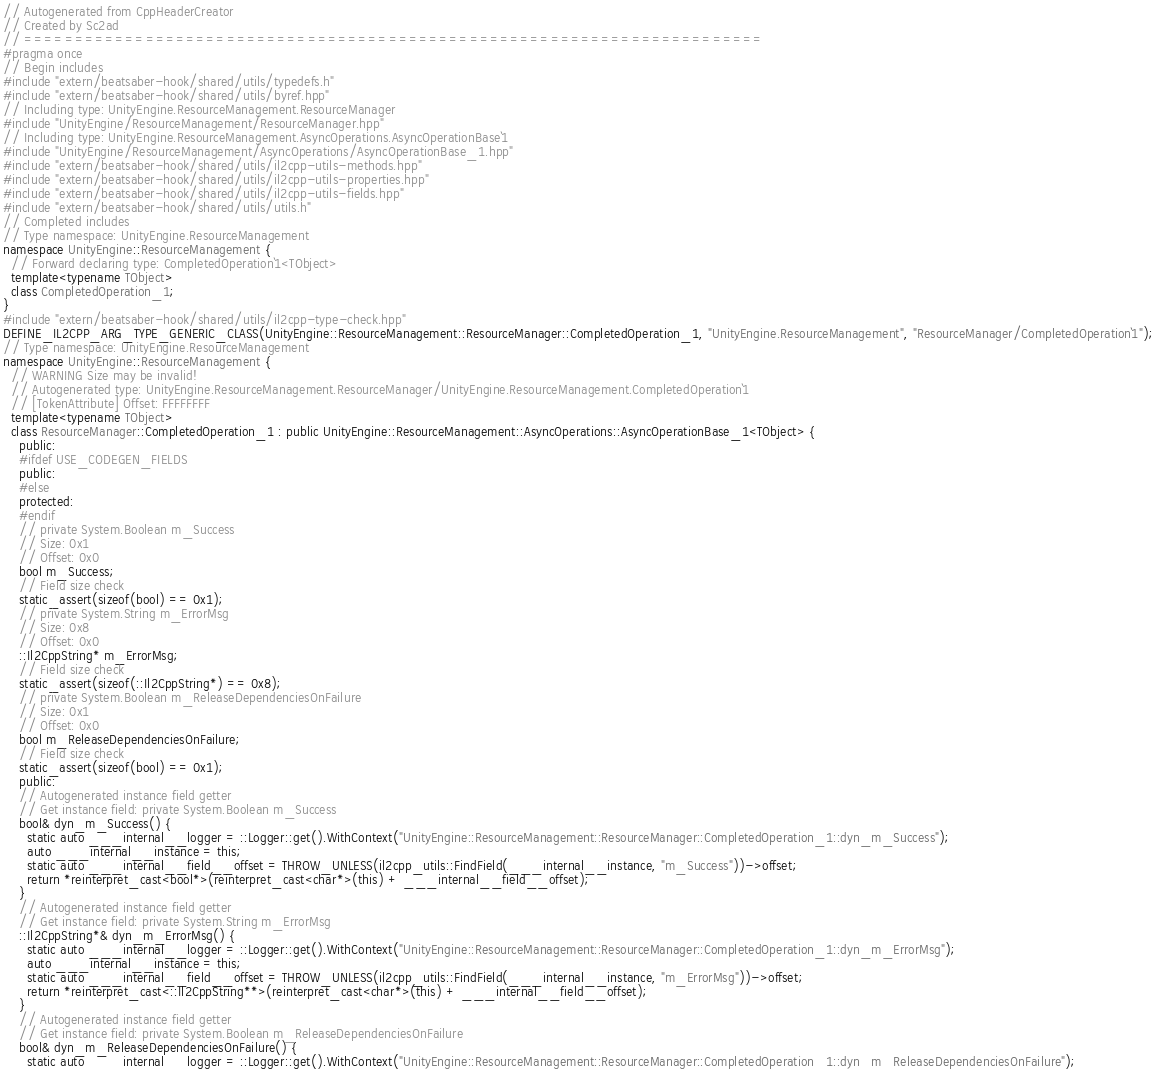<code> <loc_0><loc_0><loc_500><loc_500><_C++_>// Autogenerated from CppHeaderCreator
// Created by Sc2ad
// =========================================================================
#pragma once
// Begin includes
#include "extern/beatsaber-hook/shared/utils/typedefs.h"
#include "extern/beatsaber-hook/shared/utils/byref.hpp"
// Including type: UnityEngine.ResourceManagement.ResourceManager
#include "UnityEngine/ResourceManagement/ResourceManager.hpp"
// Including type: UnityEngine.ResourceManagement.AsyncOperations.AsyncOperationBase`1
#include "UnityEngine/ResourceManagement/AsyncOperations/AsyncOperationBase_1.hpp"
#include "extern/beatsaber-hook/shared/utils/il2cpp-utils-methods.hpp"
#include "extern/beatsaber-hook/shared/utils/il2cpp-utils-properties.hpp"
#include "extern/beatsaber-hook/shared/utils/il2cpp-utils-fields.hpp"
#include "extern/beatsaber-hook/shared/utils/utils.h"
// Completed includes
// Type namespace: UnityEngine.ResourceManagement
namespace UnityEngine::ResourceManagement {
  // Forward declaring type: CompletedOperation`1<TObject>
  template<typename TObject>
  class CompletedOperation_1;
}
#include "extern/beatsaber-hook/shared/utils/il2cpp-type-check.hpp"
DEFINE_IL2CPP_ARG_TYPE_GENERIC_CLASS(UnityEngine::ResourceManagement::ResourceManager::CompletedOperation_1, "UnityEngine.ResourceManagement", "ResourceManager/CompletedOperation`1");
// Type namespace: UnityEngine.ResourceManagement
namespace UnityEngine::ResourceManagement {
  // WARNING Size may be invalid!
  // Autogenerated type: UnityEngine.ResourceManagement.ResourceManager/UnityEngine.ResourceManagement.CompletedOperation`1
  // [TokenAttribute] Offset: FFFFFFFF
  template<typename TObject>
  class ResourceManager::CompletedOperation_1 : public UnityEngine::ResourceManagement::AsyncOperations::AsyncOperationBase_1<TObject> {
    public:
    #ifdef USE_CODEGEN_FIELDS
    public:
    #else
    protected:
    #endif
    // private System.Boolean m_Success
    // Size: 0x1
    // Offset: 0x0
    bool m_Success;
    // Field size check
    static_assert(sizeof(bool) == 0x1);
    // private System.String m_ErrorMsg
    // Size: 0x8
    // Offset: 0x0
    ::Il2CppString* m_ErrorMsg;
    // Field size check
    static_assert(sizeof(::Il2CppString*) == 0x8);
    // private System.Boolean m_ReleaseDependenciesOnFailure
    // Size: 0x1
    // Offset: 0x0
    bool m_ReleaseDependenciesOnFailure;
    // Field size check
    static_assert(sizeof(bool) == 0x1);
    public:
    // Autogenerated instance field getter
    // Get instance field: private System.Boolean m_Success
    bool& dyn_m_Success() {
      static auto ___internal__logger = ::Logger::get().WithContext("UnityEngine::ResourceManagement::ResourceManager::CompletedOperation_1::dyn_m_Success");
      auto ___internal__instance = this;
      static auto ___internal__field__offset = THROW_UNLESS(il2cpp_utils::FindField(___internal__instance, "m_Success"))->offset;
      return *reinterpret_cast<bool*>(reinterpret_cast<char*>(this) + ___internal__field__offset);
    }
    // Autogenerated instance field getter
    // Get instance field: private System.String m_ErrorMsg
    ::Il2CppString*& dyn_m_ErrorMsg() {
      static auto ___internal__logger = ::Logger::get().WithContext("UnityEngine::ResourceManagement::ResourceManager::CompletedOperation_1::dyn_m_ErrorMsg");
      auto ___internal__instance = this;
      static auto ___internal__field__offset = THROW_UNLESS(il2cpp_utils::FindField(___internal__instance, "m_ErrorMsg"))->offset;
      return *reinterpret_cast<::Il2CppString**>(reinterpret_cast<char*>(this) + ___internal__field__offset);
    }
    // Autogenerated instance field getter
    // Get instance field: private System.Boolean m_ReleaseDependenciesOnFailure
    bool& dyn_m_ReleaseDependenciesOnFailure() {
      static auto ___internal__logger = ::Logger::get().WithContext("UnityEngine::ResourceManagement::ResourceManager::CompletedOperation_1::dyn_m_ReleaseDependenciesOnFailure");</code> 